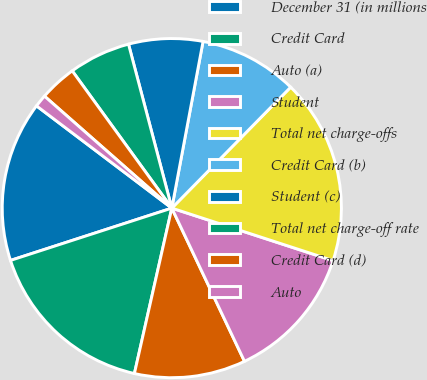Convert chart to OTSL. <chart><loc_0><loc_0><loc_500><loc_500><pie_chart><fcel>December 31 (in millions<fcel>Credit Card<fcel>Auto (a)<fcel>Student<fcel>Total net charge-offs<fcel>Credit Card (b)<fcel>Student (c)<fcel>Total net charge-off rate<fcel>Credit Card (d)<fcel>Auto<nl><fcel>15.29%<fcel>16.47%<fcel>10.59%<fcel>12.94%<fcel>17.65%<fcel>9.41%<fcel>7.06%<fcel>5.88%<fcel>3.53%<fcel>1.18%<nl></chart> 